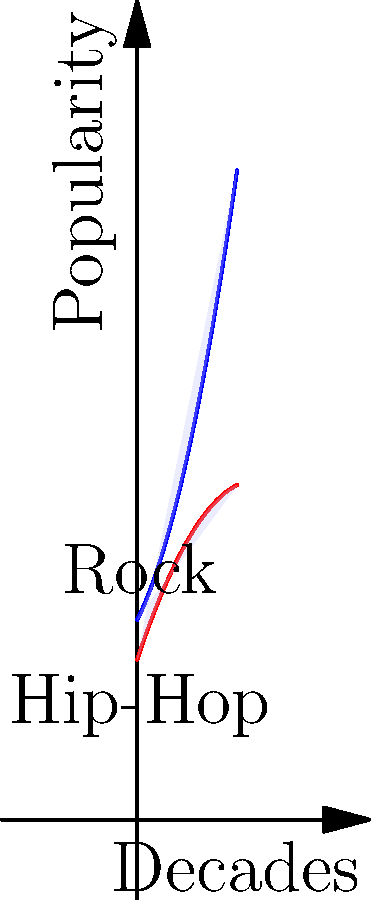The graph shows the popularity trends of Rock (blue curve) and Hip-Hop (red curve) music genres over five decades. The shaded area between the curves represents the cumulative difference in popularity between the two genres. As a psychologist analyzing pop culture trends, calculate the definite integral that represents this shaded area. How might this quantitative measure inform your understanding of the psychological impact of these genres on different generations? To solve this problem, we need to follow these steps:

1) Identify the functions:
   Rock (blue): $f(x) = 0.5x^2 + 2x + 10$
   Hip-Hop (red): $g(x) = -0.25x^2 + 3x + 8$

2) The shaded area is the difference between these functions:
   $h(x) = f(x) - g(x) = (0.5x^2 + 2x + 10) - (-0.25x^2 + 3x + 8)$
                        $= 0.75x^2 - x + 2$

3) To find the area, we need to integrate $h(x)$ from 0 to 5:

   $$\int_0^5 (0.75x^2 - x + 2) dx$$

4) Integrate each term:
   $$[\frac{0.75x^3}{3} - \frac{x^2}{2} + 2x]_0^5$$

5) Evaluate at the limits:
   $$(\frac{0.75(5^3)}{3} - \frac{5^2}{2} + 2(5)) - (\frac{0.75(0^3)}{3} - \frac{0^2}{2} + 2(0))$$
   $$= (31.25 - 12.5 + 10) - 0 = 28.75$$

The definite integral, representing the cumulative difference in popularity between Rock and Hip-Hop over five decades, is 28.75 units.

From a psychological perspective, this quantitative measure could inform our understanding of the generational impact of these genres in several ways:

1) It provides a numerical representation of the overall dominance of Rock over Hip-Hop during this period, which could correlate with cultural identity formation across generations.

2) The changing difference over time (as seen in the varying width of the shaded area) could indicate shifts in societal values, attitudes, or emotional expressions that each genre represents.

3) Points where the curves intersect might represent pivotal moments of cultural shift, potentially aligning with significant societal changes or events that a psychologist would find relevant in studying collective behavior and mindset.

4) The rate of change in popularity for each genre could offer insights into the speed of cultural adoption and the psychological mechanisms behind trend-following behavior.

This quantitative analysis, combined with qualitative research, could provide a more comprehensive understanding of how music genres influence and reflect psychological and social dynamics across generations.
Answer: 28.75 units 